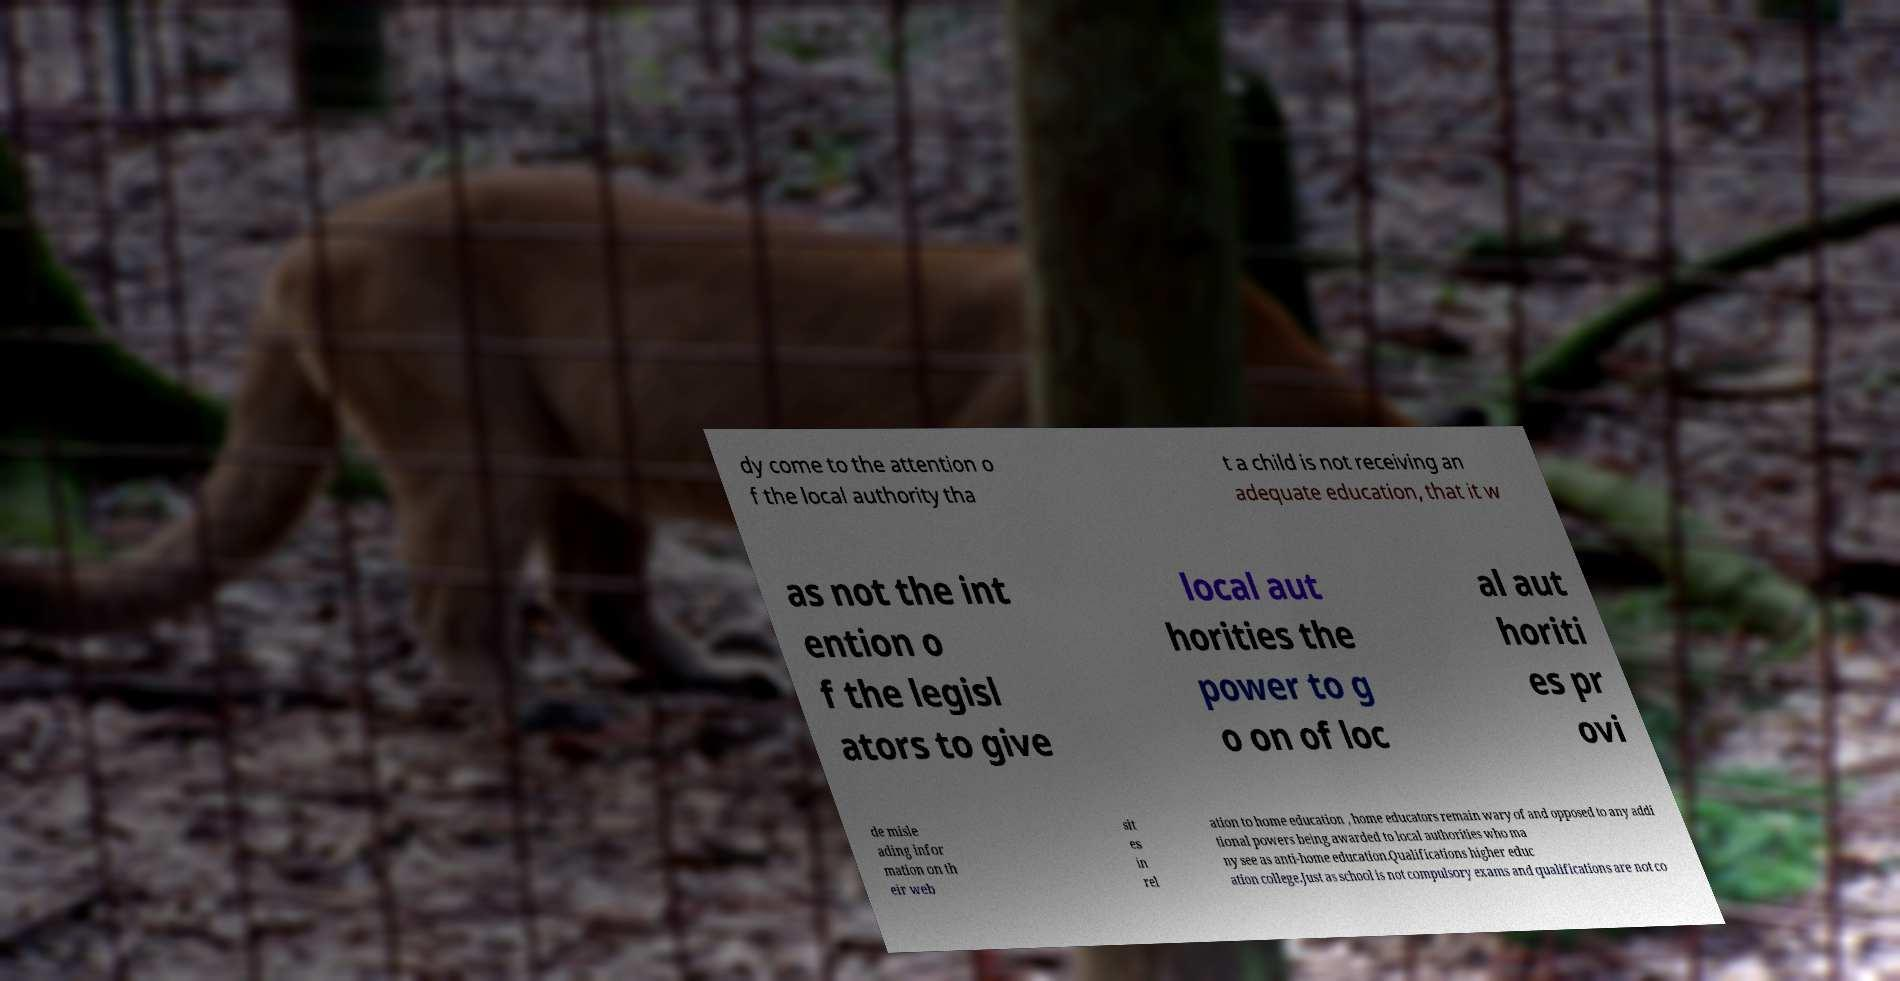Please identify and transcribe the text found in this image. dy come to the attention o f the local authority tha t a child is not receiving an adequate education, that it w as not the int ention o f the legisl ators to give local aut horities the power to g o on of loc al aut horiti es pr ovi de misle ading infor mation on th eir web sit es in rel ation to home education , home educators remain wary of and opposed to any addi tional powers being awarded to local authorities who ma ny see as anti-home education.Qualifications higher educ ation college.Just as school is not compulsory exams and qualifications are not co 